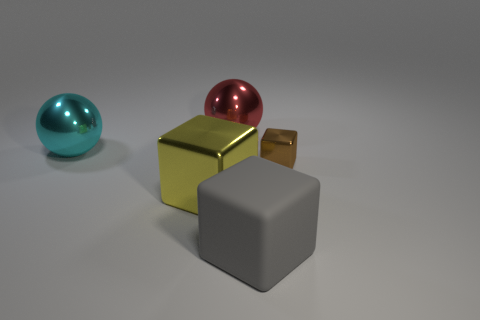Is there anything else that has the same color as the rubber cube?
Your response must be concise. No. Is the material of the sphere behind the large cyan thing the same as the cube that is left of the red shiny sphere?
Ensure brevity in your answer.  Yes. What number of objects are either large red shiny balls or big cubes that are on the right side of the big yellow metallic thing?
Ensure brevity in your answer.  2. Is there any other thing that has the same material as the big gray thing?
Ensure brevity in your answer.  No. What material is the red thing?
Offer a terse response. Metal. Does the tiny brown object have the same material as the red sphere?
Keep it short and to the point. Yes. What number of matte objects are either yellow objects or small blue balls?
Your answer should be very brief. 0. What is the shape of the big object that is in front of the large yellow metallic cube?
Your answer should be very brief. Cube. What size is the red thing that is the same material as the large cyan thing?
Make the answer very short. Large. There is a big object that is both in front of the tiny metallic block and to the left of the big gray rubber cube; what is its shape?
Provide a succinct answer. Cube. 